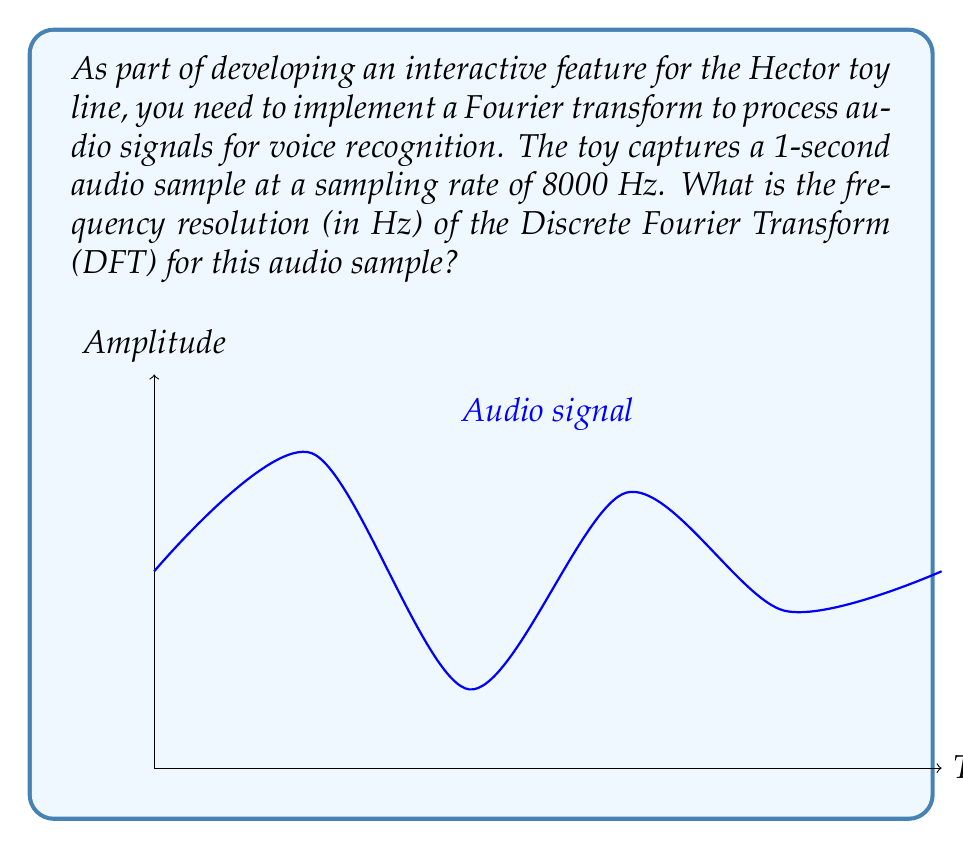Teach me how to tackle this problem. To solve this problem, we need to understand the relationship between the Discrete Fourier Transform (DFT), sampling rate, and frequency resolution. Let's break it down step-by-step:

1) The frequency resolution of a DFT is given by the formula:

   $$\Delta f = \frac{f_s}{N}$$

   Where:
   - $\Delta f$ is the frequency resolution
   - $f_s$ is the sampling rate
   - $N$ is the number of samples

2) We're given the sampling rate $f_s = 8000$ Hz.

3) To find $N$, we need to calculate the number of samples in a 1-second audio clip:
   
   $$N = f_s \times \text{duration} = 8000 \times 1 = 8000 \text{ samples}$$

4) Now we can plug these values into our frequency resolution formula:

   $$\Delta f = \frac{f_s}{N} = \frac{8000 \text{ Hz}}{8000 \text{ samples}} = 1 \text{ Hz}$$

Therefore, the frequency resolution of the DFT for this audio sample is 1 Hz.
Answer: 1 Hz 